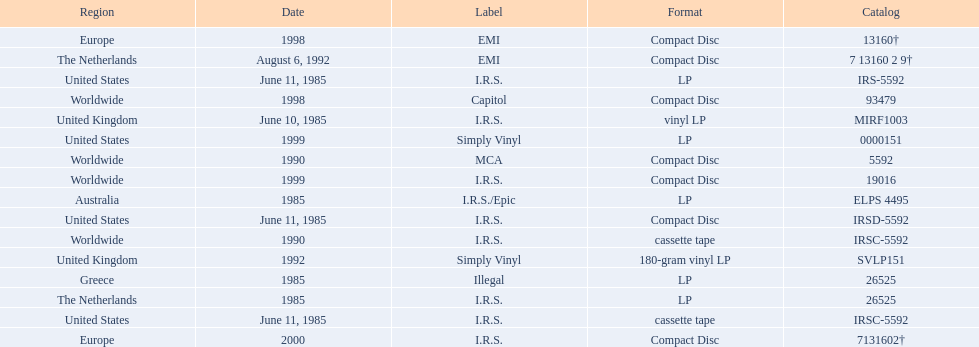Which dates were their releases by fables of the reconstruction? June 10, 1985, June 11, 1985, June 11, 1985, June 11, 1985, 1985, 1985, 1985, 1990, 1990, August 6, 1992, 1992, 1998, 1998, 1999, 1999, 2000. Which of these are in 1985? June 10, 1985, June 11, 1985, June 11, 1985, June 11, 1985, 1985, 1985, 1985. What regions were there releases on these dates? United Kingdom, United States, United States, United States, Greece, Australia, The Netherlands. Which of these are not greece? United Kingdom, United States, United States, United States, Australia, The Netherlands. Which of these regions have two labels listed? Australia. 